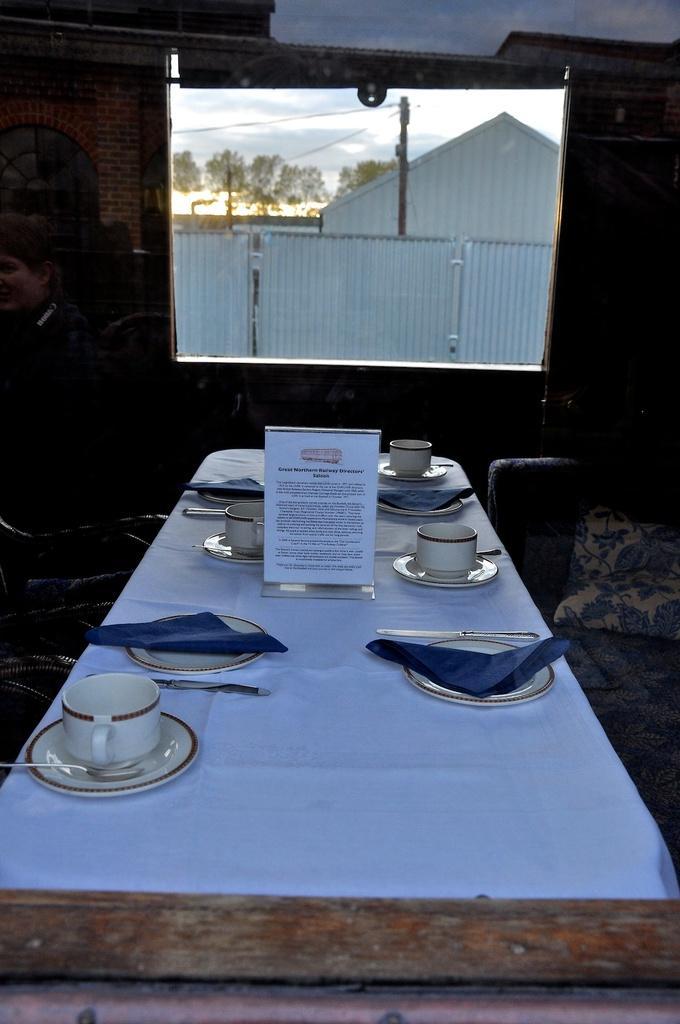Please provide a concise description of this image. In the picture we can find a table, tablecloth, some cup and saucers and tissues. From the window we can find houses, trees,sky and one pole. 